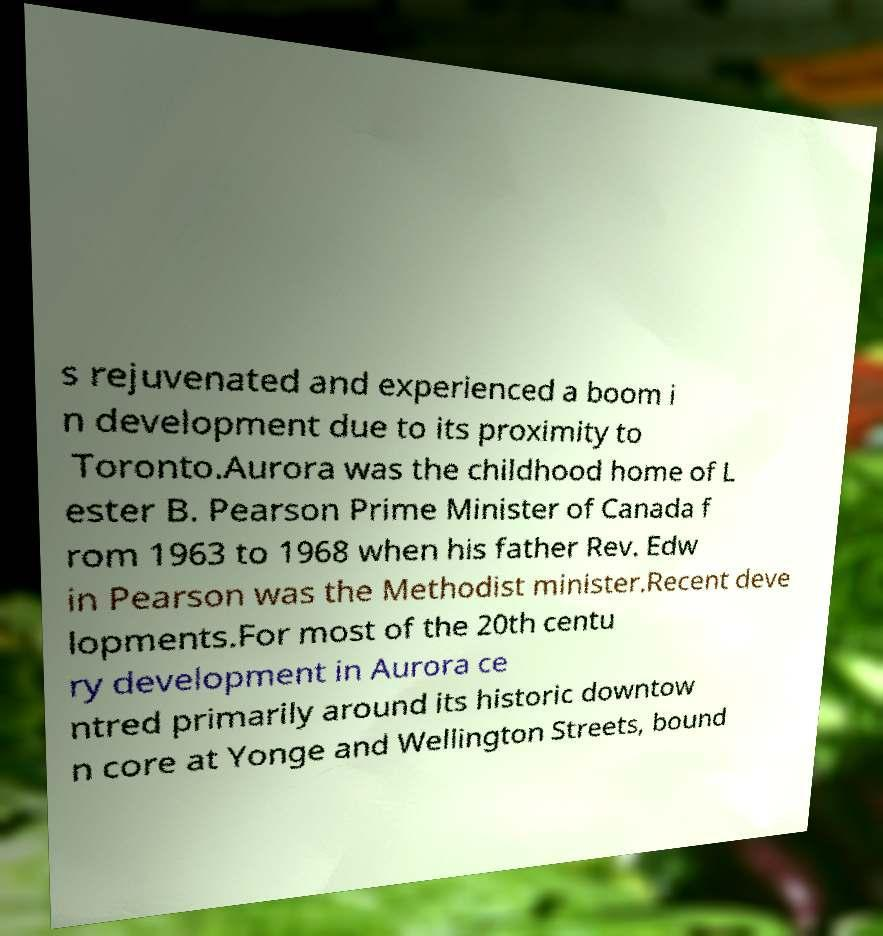I need the written content from this picture converted into text. Can you do that? s rejuvenated and experienced a boom i n development due to its proximity to Toronto.Aurora was the childhood home of L ester B. Pearson Prime Minister of Canada f rom 1963 to 1968 when his father Rev. Edw in Pearson was the Methodist minister.Recent deve lopments.For most of the 20th centu ry development in Aurora ce ntred primarily around its historic downtow n core at Yonge and Wellington Streets, bound 